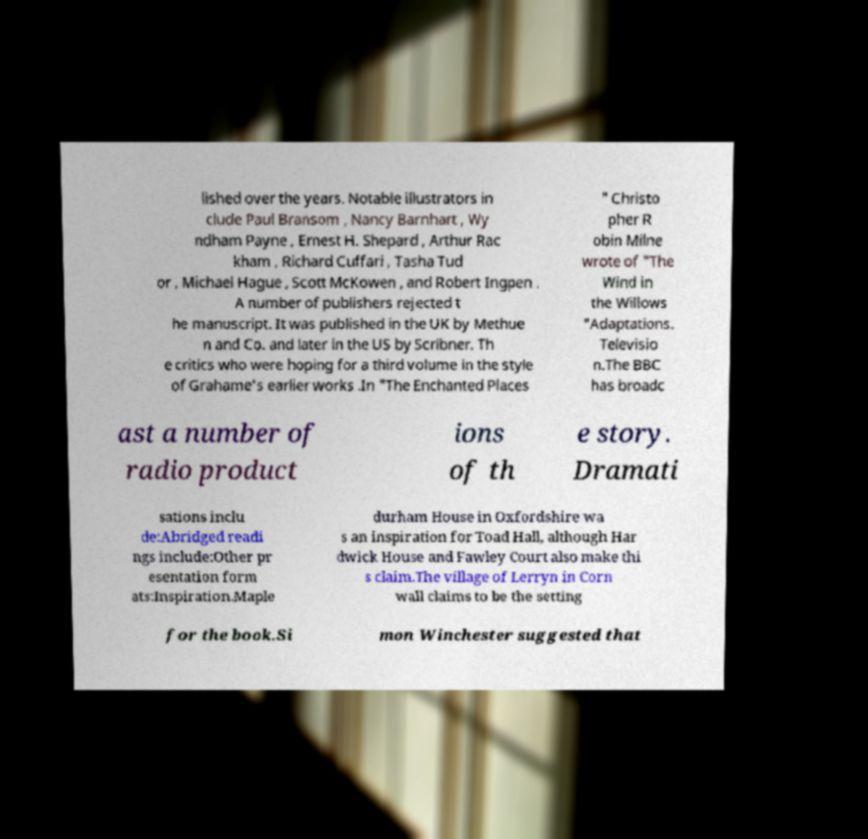Please identify and transcribe the text found in this image. lished over the years. Notable illustrators in clude Paul Bransom , Nancy Barnhart , Wy ndham Payne , Ernest H. Shepard , Arthur Rac kham , Richard Cuffari , Tasha Tud or , Michael Hague , Scott McKowen , and Robert Ingpen . A number of publishers rejected t he manuscript. It was published in the UK by Methue n and Co. and later in the US by Scribner. Th e critics who were hoping for a third volume in the style of Grahame's earlier works .In "The Enchanted Places " Christo pher R obin Milne wrote of "The Wind in the Willows "Adaptations. Televisio n.The BBC has broadc ast a number of radio product ions of th e story. Dramati sations inclu de:Abridged readi ngs include:Other pr esentation form ats:Inspiration.Maple durham House in Oxfordshire wa s an inspiration for Toad Hall, although Har dwick House and Fawley Court also make thi s claim.The village of Lerryn in Corn wall claims to be the setting for the book.Si mon Winchester suggested that 